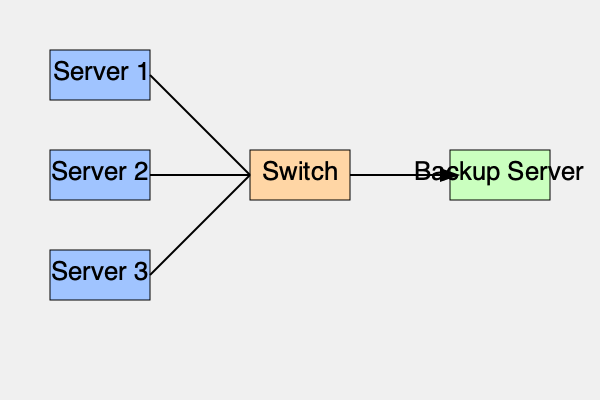In the network topology shown, what is the most efficient path for backup data to flow from Server 2 to the Backup Server? To determine the most efficient path for backup data to flow from Server 2 to the Backup Server, let's analyze the network topology step-by-step:

1. Server 2 is directly connected to the central Switch.
2. The Backup Server is also directly connected to the same Switch.
3. There are no alternative routes or intermediate devices between the Switch and the Backup Server.

The most efficient path would be:

1. Data leaves Server 2.
2. It travels directly to the Switch.
3. From the Switch, it goes straight to the Backup Server.

This path minimizes the number of hops and potential points of congestion or failure. It allows for the fastest and most reliable data transfer, which is crucial for a backup solution in a large enterprise environment.

The arrow in the diagram indicates this direct flow of data from the Switch to the Backup Server, which would be the same for all servers in this star topology.
Answer: Server 2 → Switch → Backup Server 